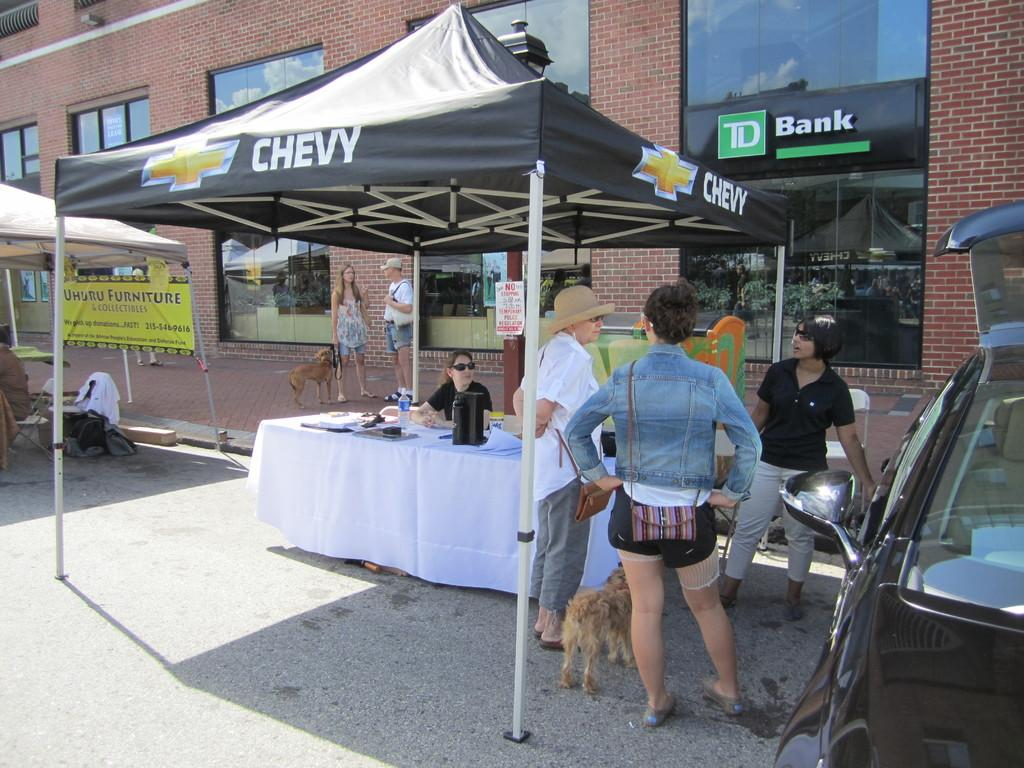What is happening in the image involving the people and their dogs? The people in the image are standing with their dogs. What can be seen on the table in the image? There is a water bottle and a flask on the table. Can you describe the seating arrangement in the image? There is a woman sitting on a chair in the image. What is the price of the trousers worn by the woman in the image? There is no information about the price of the woman's trousers, nor are trousers mentioned in the provided facts. 